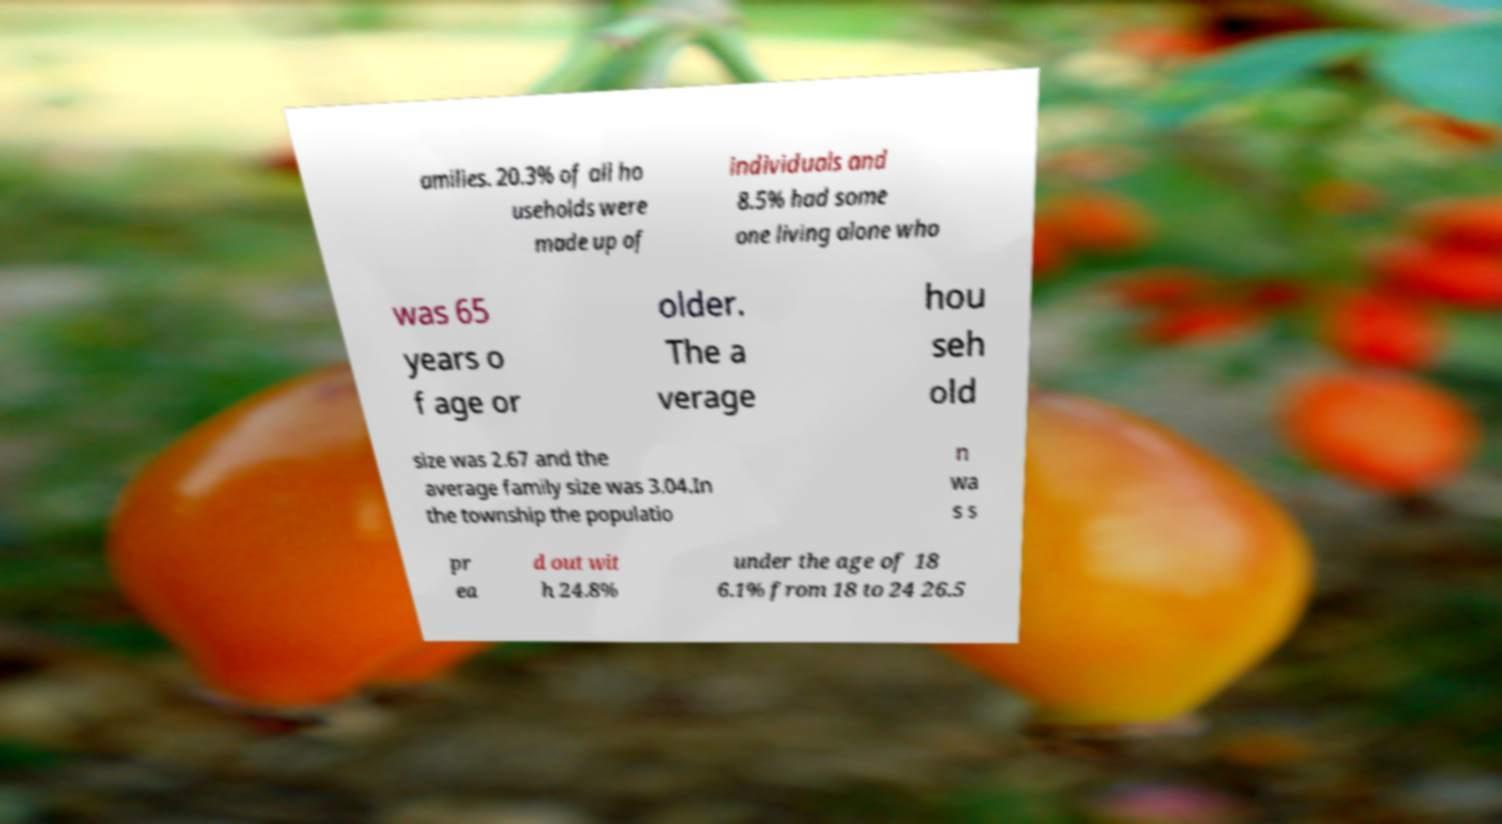Could you assist in decoding the text presented in this image and type it out clearly? amilies. 20.3% of all ho useholds were made up of individuals and 8.5% had some one living alone who was 65 years o f age or older. The a verage hou seh old size was 2.67 and the average family size was 3.04.In the township the populatio n wa s s pr ea d out wit h 24.8% under the age of 18 6.1% from 18 to 24 26.5 